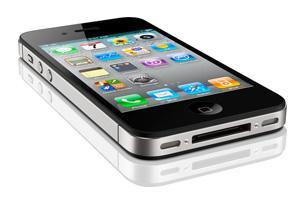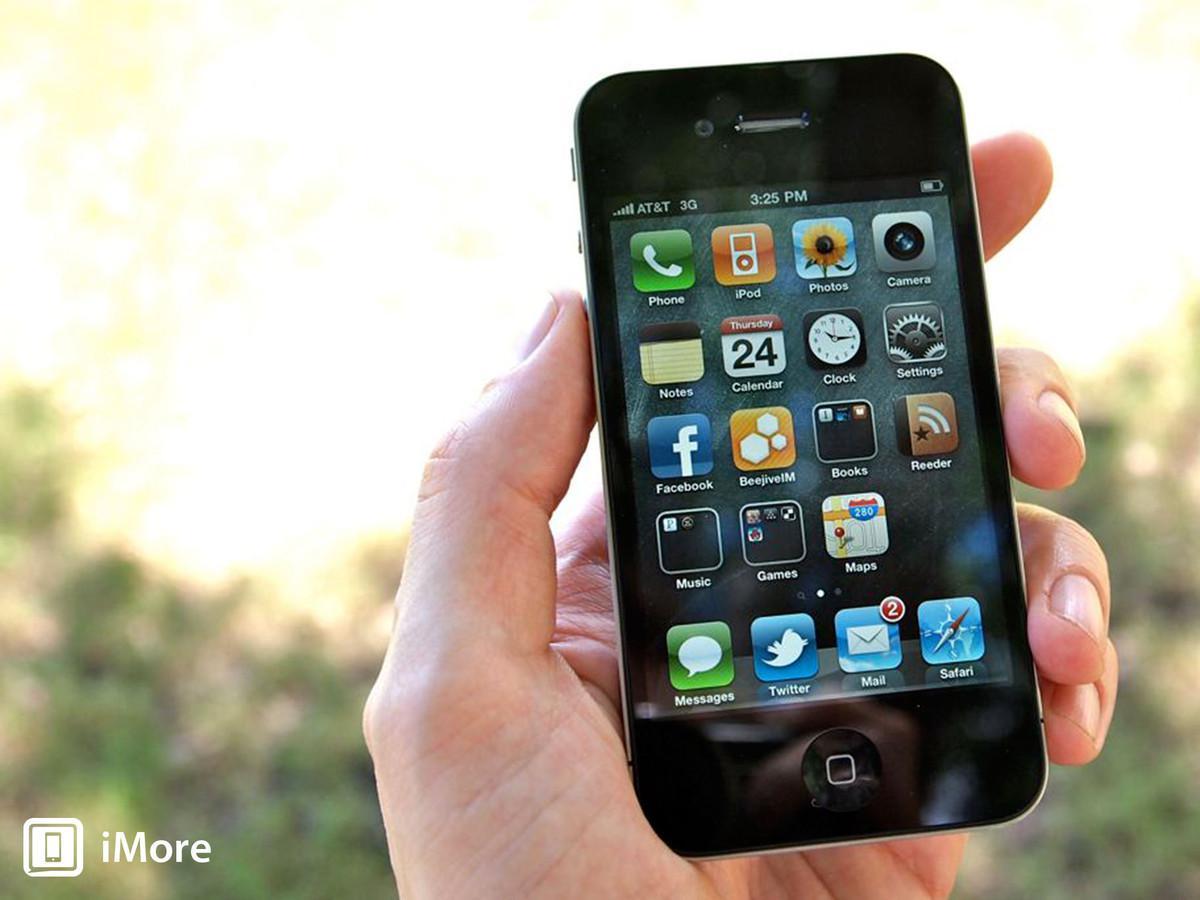The first image is the image on the left, the second image is the image on the right. Given the left and right images, does the statement "A phone sits alone in the image on the left, while the phone in the image on the right is held." hold true? Answer yes or no. Yes. The first image is the image on the left, the second image is the image on the right. Analyze the images presented: Is the assertion "The right image features a black phone held by a hand with the thumb on the right, and the left image contains at least one phone but no hand." valid? Answer yes or no. Yes. 